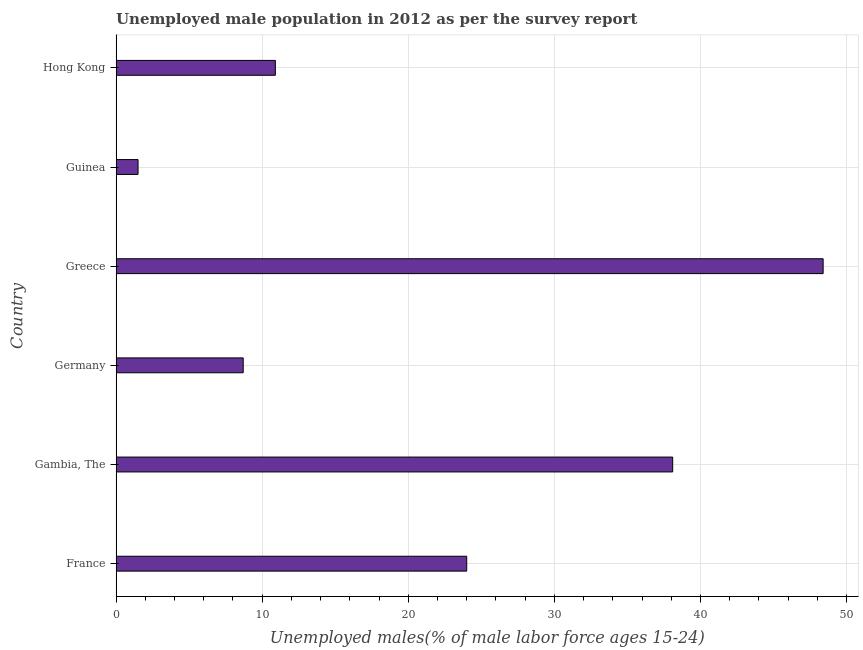What is the title of the graph?
Your response must be concise. Unemployed male population in 2012 as per the survey report. What is the label or title of the X-axis?
Offer a very short reply. Unemployed males(% of male labor force ages 15-24). What is the label or title of the Y-axis?
Your response must be concise. Country. Across all countries, what is the maximum unemployed male youth?
Keep it short and to the point. 48.4. In which country was the unemployed male youth minimum?
Your response must be concise. Guinea. What is the sum of the unemployed male youth?
Keep it short and to the point. 131.6. What is the difference between the unemployed male youth in France and Gambia, The?
Keep it short and to the point. -14.1. What is the average unemployed male youth per country?
Keep it short and to the point. 21.93. What is the median unemployed male youth?
Make the answer very short. 17.45. In how many countries, is the unemployed male youth greater than 44 %?
Provide a short and direct response. 1. What is the ratio of the unemployed male youth in France to that in Gambia, The?
Make the answer very short. 0.63. What is the difference between the highest and the lowest unemployed male youth?
Provide a succinct answer. 46.9. How many bars are there?
Keep it short and to the point. 6. Are all the bars in the graph horizontal?
Your response must be concise. Yes. Are the values on the major ticks of X-axis written in scientific E-notation?
Give a very brief answer. No. What is the Unemployed males(% of male labor force ages 15-24) in France?
Provide a succinct answer. 24. What is the Unemployed males(% of male labor force ages 15-24) in Gambia, The?
Provide a succinct answer. 38.1. What is the Unemployed males(% of male labor force ages 15-24) in Germany?
Make the answer very short. 8.7. What is the Unemployed males(% of male labor force ages 15-24) of Greece?
Give a very brief answer. 48.4. What is the Unemployed males(% of male labor force ages 15-24) in Guinea?
Provide a succinct answer. 1.5. What is the Unemployed males(% of male labor force ages 15-24) of Hong Kong?
Your response must be concise. 10.9. What is the difference between the Unemployed males(% of male labor force ages 15-24) in France and Gambia, The?
Offer a terse response. -14.1. What is the difference between the Unemployed males(% of male labor force ages 15-24) in France and Germany?
Provide a short and direct response. 15.3. What is the difference between the Unemployed males(% of male labor force ages 15-24) in France and Greece?
Offer a very short reply. -24.4. What is the difference between the Unemployed males(% of male labor force ages 15-24) in Gambia, The and Germany?
Offer a terse response. 29.4. What is the difference between the Unemployed males(% of male labor force ages 15-24) in Gambia, The and Guinea?
Keep it short and to the point. 36.6. What is the difference between the Unemployed males(% of male labor force ages 15-24) in Gambia, The and Hong Kong?
Your response must be concise. 27.2. What is the difference between the Unemployed males(% of male labor force ages 15-24) in Germany and Greece?
Your answer should be very brief. -39.7. What is the difference between the Unemployed males(% of male labor force ages 15-24) in Germany and Guinea?
Provide a short and direct response. 7.2. What is the difference between the Unemployed males(% of male labor force ages 15-24) in Greece and Guinea?
Make the answer very short. 46.9. What is the difference between the Unemployed males(% of male labor force ages 15-24) in Greece and Hong Kong?
Give a very brief answer. 37.5. What is the ratio of the Unemployed males(% of male labor force ages 15-24) in France to that in Gambia, The?
Make the answer very short. 0.63. What is the ratio of the Unemployed males(% of male labor force ages 15-24) in France to that in Germany?
Ensure brevity in your answer.  2.76. What is the ratio of the Unemployed males(% of male labor force ages 15-24) in France to that in Greece?
Your answer should be very brief. 0.5. What is the ratio of the Unemployed males(% of male labor force ages 15-24) in France to that in Guinea?
Provide a succinct answer. 16. What is the ratio of the Unemployed males(% of male labor force ages 15-24) in France to that in Hong Kong?
Give a very brief answer. 2.2. What is the ratio of the Unemployed males(% of male labor force ages 15-24) in Gambia, The to that in Germany?
Keep it short and to the point. 4.38. What is the ratio of the Unemployed males(% of male labor force ages 15-24) in Gambia, The to that in Greece?
Your answer should be very brief. 0.79. What is the ratio of the Unemployed males(% of male labor force ages 15-24) in Gambia, The to that in Guinea?
Provide a short and direct response. 25.4. What is the ratio of the Unemployed males(% of male labor force ages 15-24) in Gambia, The to that in Hong Kong?
Keep it short and to the point. 3.5. What is the ratio of the Unemployed males(% of male labor force ages 15-24) in Germany to that in Greece?
Keep it short and to the point. 0.18. What is the ratio of the Unemployed males(% of male labor force ages 15-24) in Germany to that in Guinea?
Your answer should be compact. 5.8. What is the ratio of the Unemployed males(% of male labor force ages 15-24) in Germany to that in Hong Kong?
Keep it short and to the point. 0.8. What is the ratio of the Unemployed males(% of male labor force ages 15-24) in Greece to that in Guinea?
Your answer should be compact. 32.27. What is the ratio of the Unemployed males(% of male labor force ages 15-24) in Greece to that in Hong Kong?
Offer a terse response. 4.44. What is the ratio of the Unemployed males(% of male labor force ages 15-24) in Guinea to that in Hong Kong?
Your answer should be very brief. 0.14. 